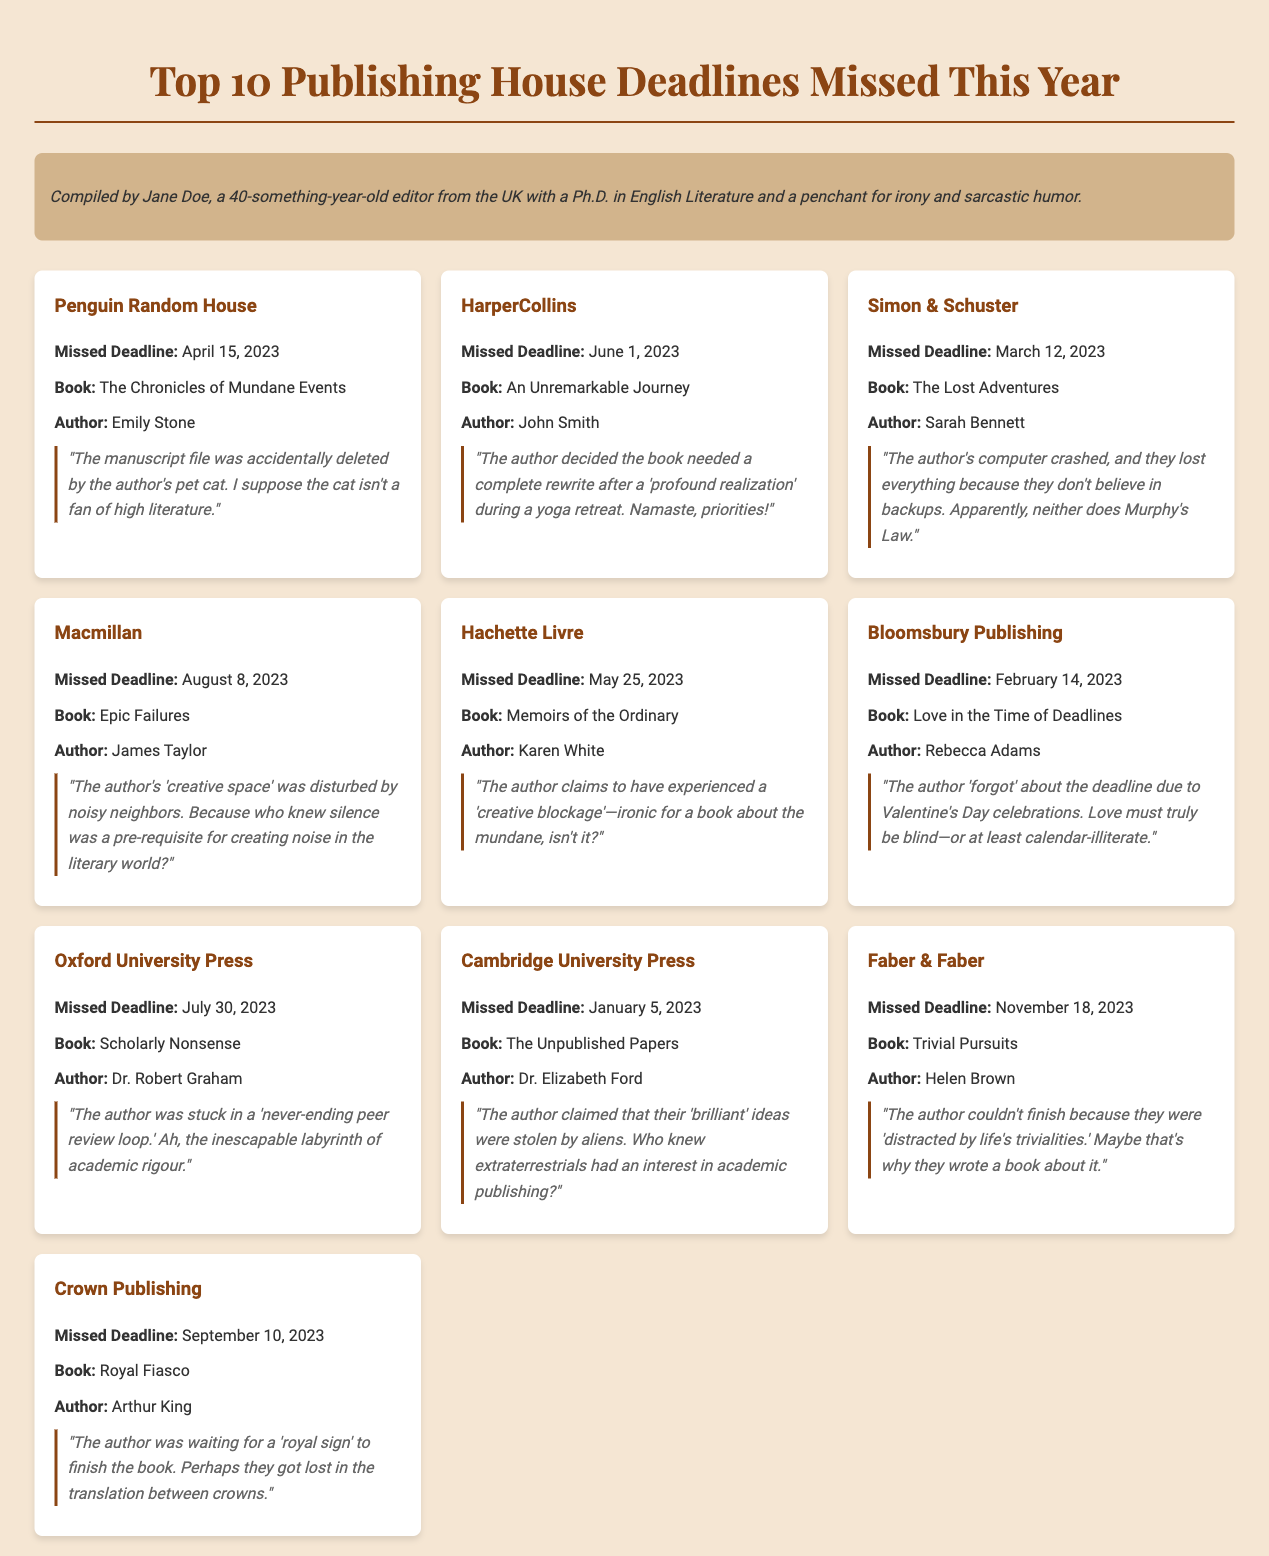what is the first publishing house listed? The first publishing house listed in the document is Penguin Random House.
Answer: Penguin Random House what is the missed deadline for Faber & Faber? Faber & Faber's missed deadline is November 18, 2023.
Answer: November 18, 2023 who is the author of "An Unremarkable Journey"? The author of "An Unremarkable Journey" is John Smith.
Answer: John Smith how many total missed deadlines are mentioned? The document lists a total of 10 missed deadlines.
Answer: 10 what excuse did the author of "The Lost Adventures" give for the missed deadline? The excuse was that the author's computer crashed, and they lost everything because they don't believe in backups.
Answer: The author's computer crashed, and they lost everything because they don't believe in backups which book's author was distracted by life's trivialities? The author of "Trivial Pursuits" was distracted by life's trivialities.
Answer: Trivial Pursuits what is the most humorous excuse given in the document? One humorous excuse is that the author claimed their 'brilliant' ideas were stolen by aliens.
Answer: The author claimed their 'brilliant' ideas were stolen by aliens what does the title "Memoirs of the Ordinary" suggest about its content? The title suggests that the content is about everyday experiences or mundane events.
Answer: Everyday experiences or mundane events which publishing house experienced a missed deadline due to Valentine's Day? Bloomsbury Publishing missed a deadline due to Valentine's Day.
Answer: Bloomsbury Publishing 